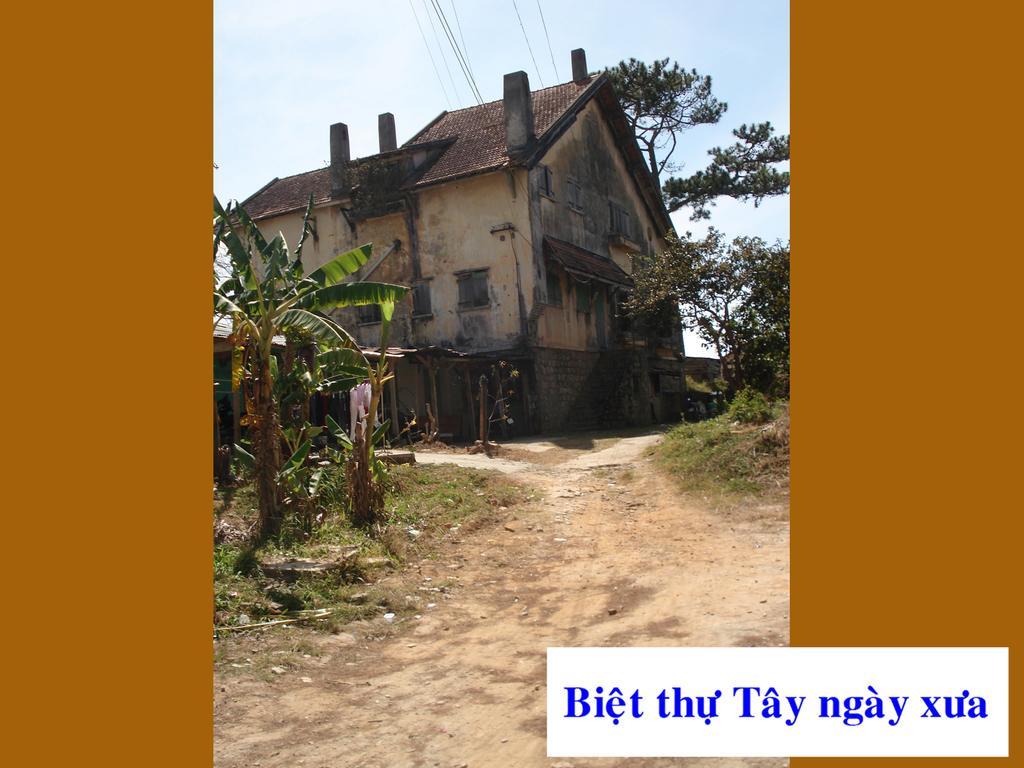In one or two sentences, can you explain what this image depicts? In the foreground of this image, there is a path and few trees are on the either side to the path. In the background, there is a house. On the top, there are cables, sky and the cloud. On the either side of this image, there is an orange border. 